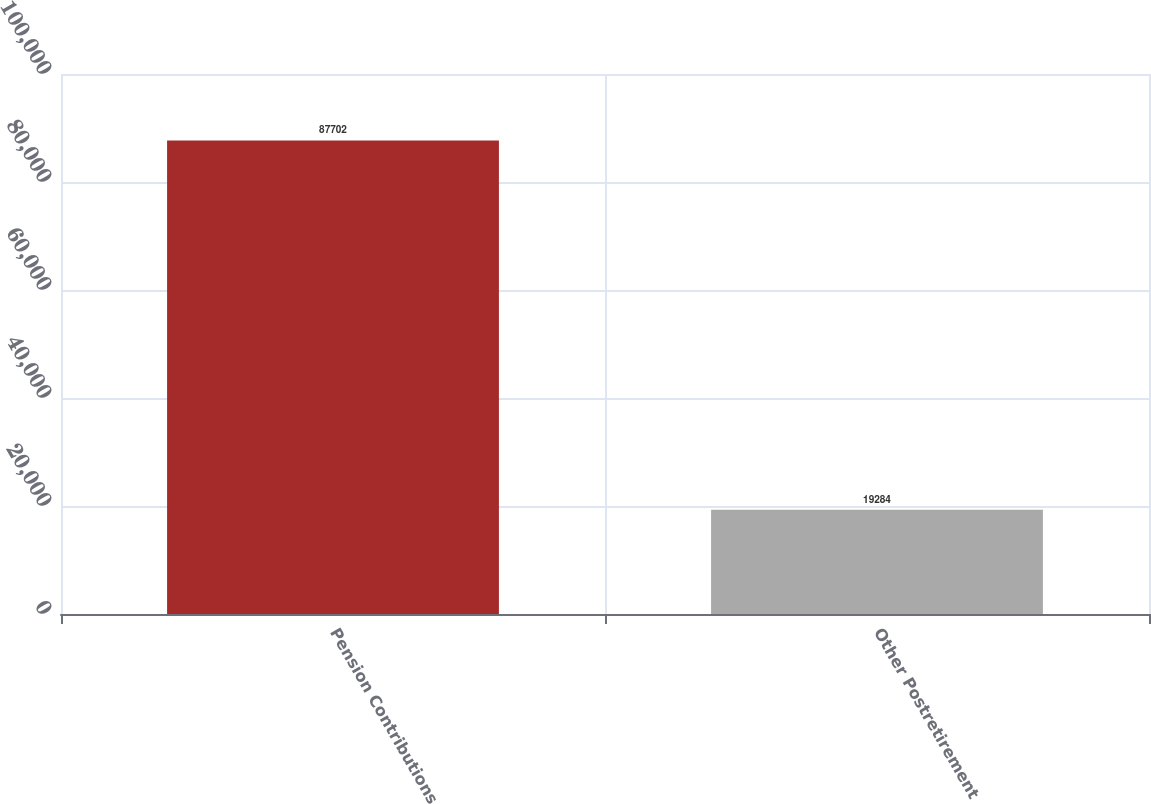<chart> <loc_0><loc_0><loc_500><loc_500><bar_chart><fcel>Pension Contributions<fcel>Other Postretirement<nl><fcel>87702<fcel>19284<nl></chart> 